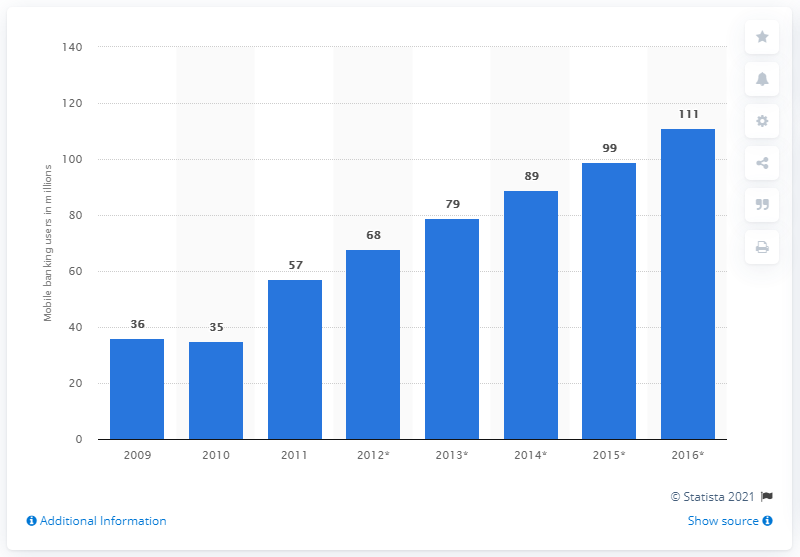Give some essential details in this illustration. By 2014, it is estimated that 89 people will be accessing mobile banking services. 